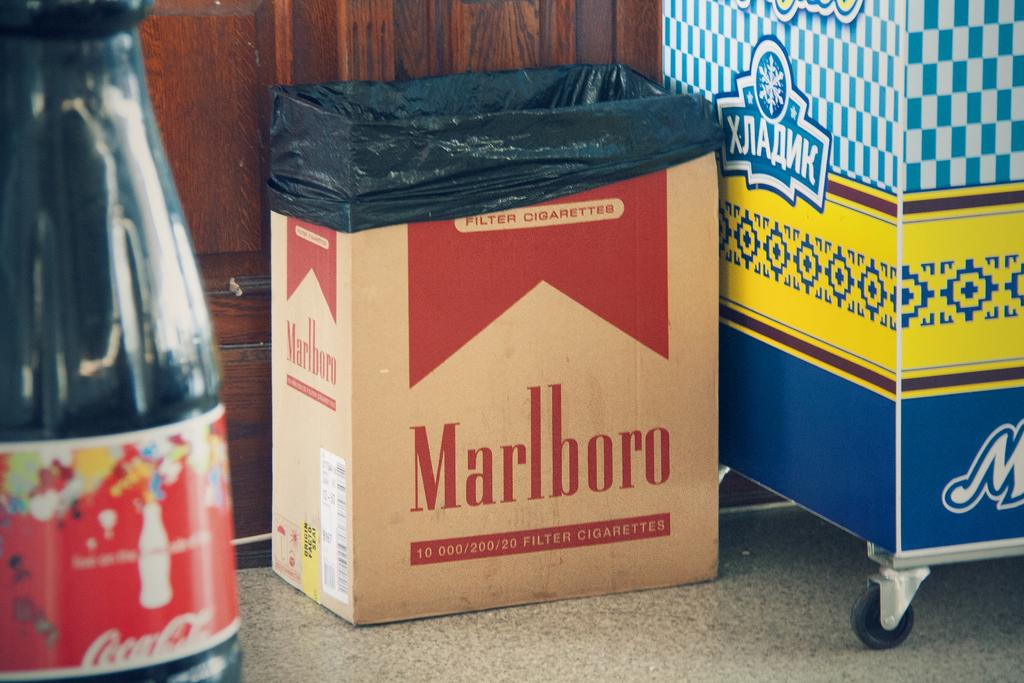<image>
Render a clear and concise summary of the photo. a box reading Marlboro is on the floor with a black bag in it 